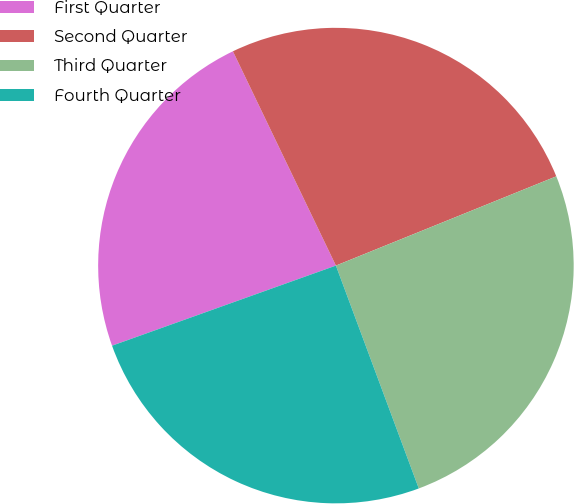Convert chart. <chart><loc_0><loc_0><loc_500><loc_500><pie_chart><fcel>First Quarter<fcel>Second Quarter<fcel>Third Quarter<fcel>Fourth Quarter<nl><fcel>23.34%<fcel>26.01%<fcel>25.46%<fcel>25.2%<nl></chart> 